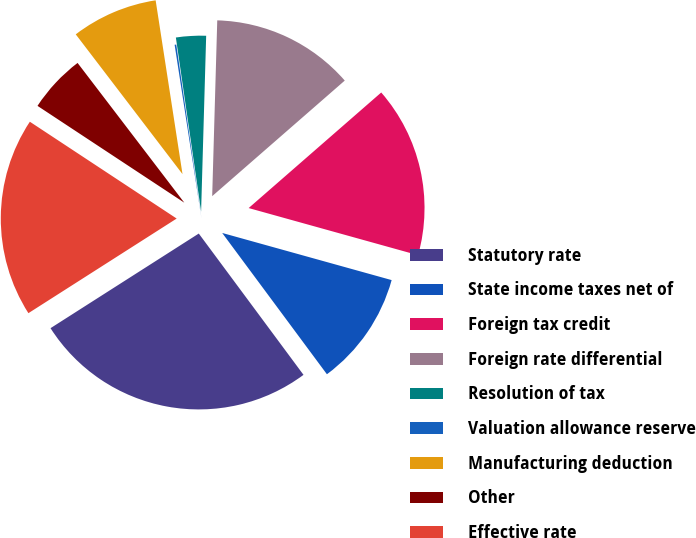Convert chart to OTSL. <chart><loc_0><loc_0><loc_500><loc_500><pie_chart><fcel>Statutory rate<fcel>State income taxes net of<fcel>Foreign tax credit<fcel>Foreign rate differential<fcel>Resolution of tax<fcel>Valuation allowance reserve<fcel>Manufacturing deduction<fcel>Other<fcel>Effective rate<nl><fcel>26.11%<fcel>10.53%<fcel>15.73%<fcel>13.13%<fcel>2.75%<fcel>0.15%<fcel>7.94%<fcel>5.34%<fcel>18.32%<nl></chart> 